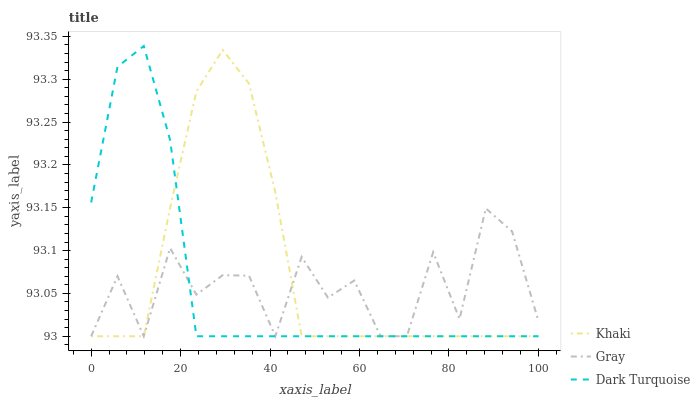Does Dark Turquoise have the minimum area under the curve?
Answer yes or no. Yes. Does Khaki have the maximum area under the curve?
Answer yes or no. Yes. Does Khaki have the minimum area under the curve?
Answer yes or no. No. Does Dark Turquoise have the maximum area under the curve?
Answer yes or no. No. Is Dark Turquoise the smoothest?
Answer yes or no. Yes. Is Gray the roughest?
Answer yes or no. Yes. Is Khaki the smoothest?
Answer yes or no. No. Is Khaki the roughest?
Answer yes or no. No. Does Gray have the lowest value?
Answer yes or no. Yes. Does Dark Turquoise have the highest value?
Answer yes or no. Yes. Does Khaki have the highest value?
Answer yes or no. No. Does Khaki intersect Gray?
Answer yes or no. Yes. Is Khaki less than Gray?
Answer yes or no. No. Is Khaki greater than Gray?
Answer yes or no. No. 